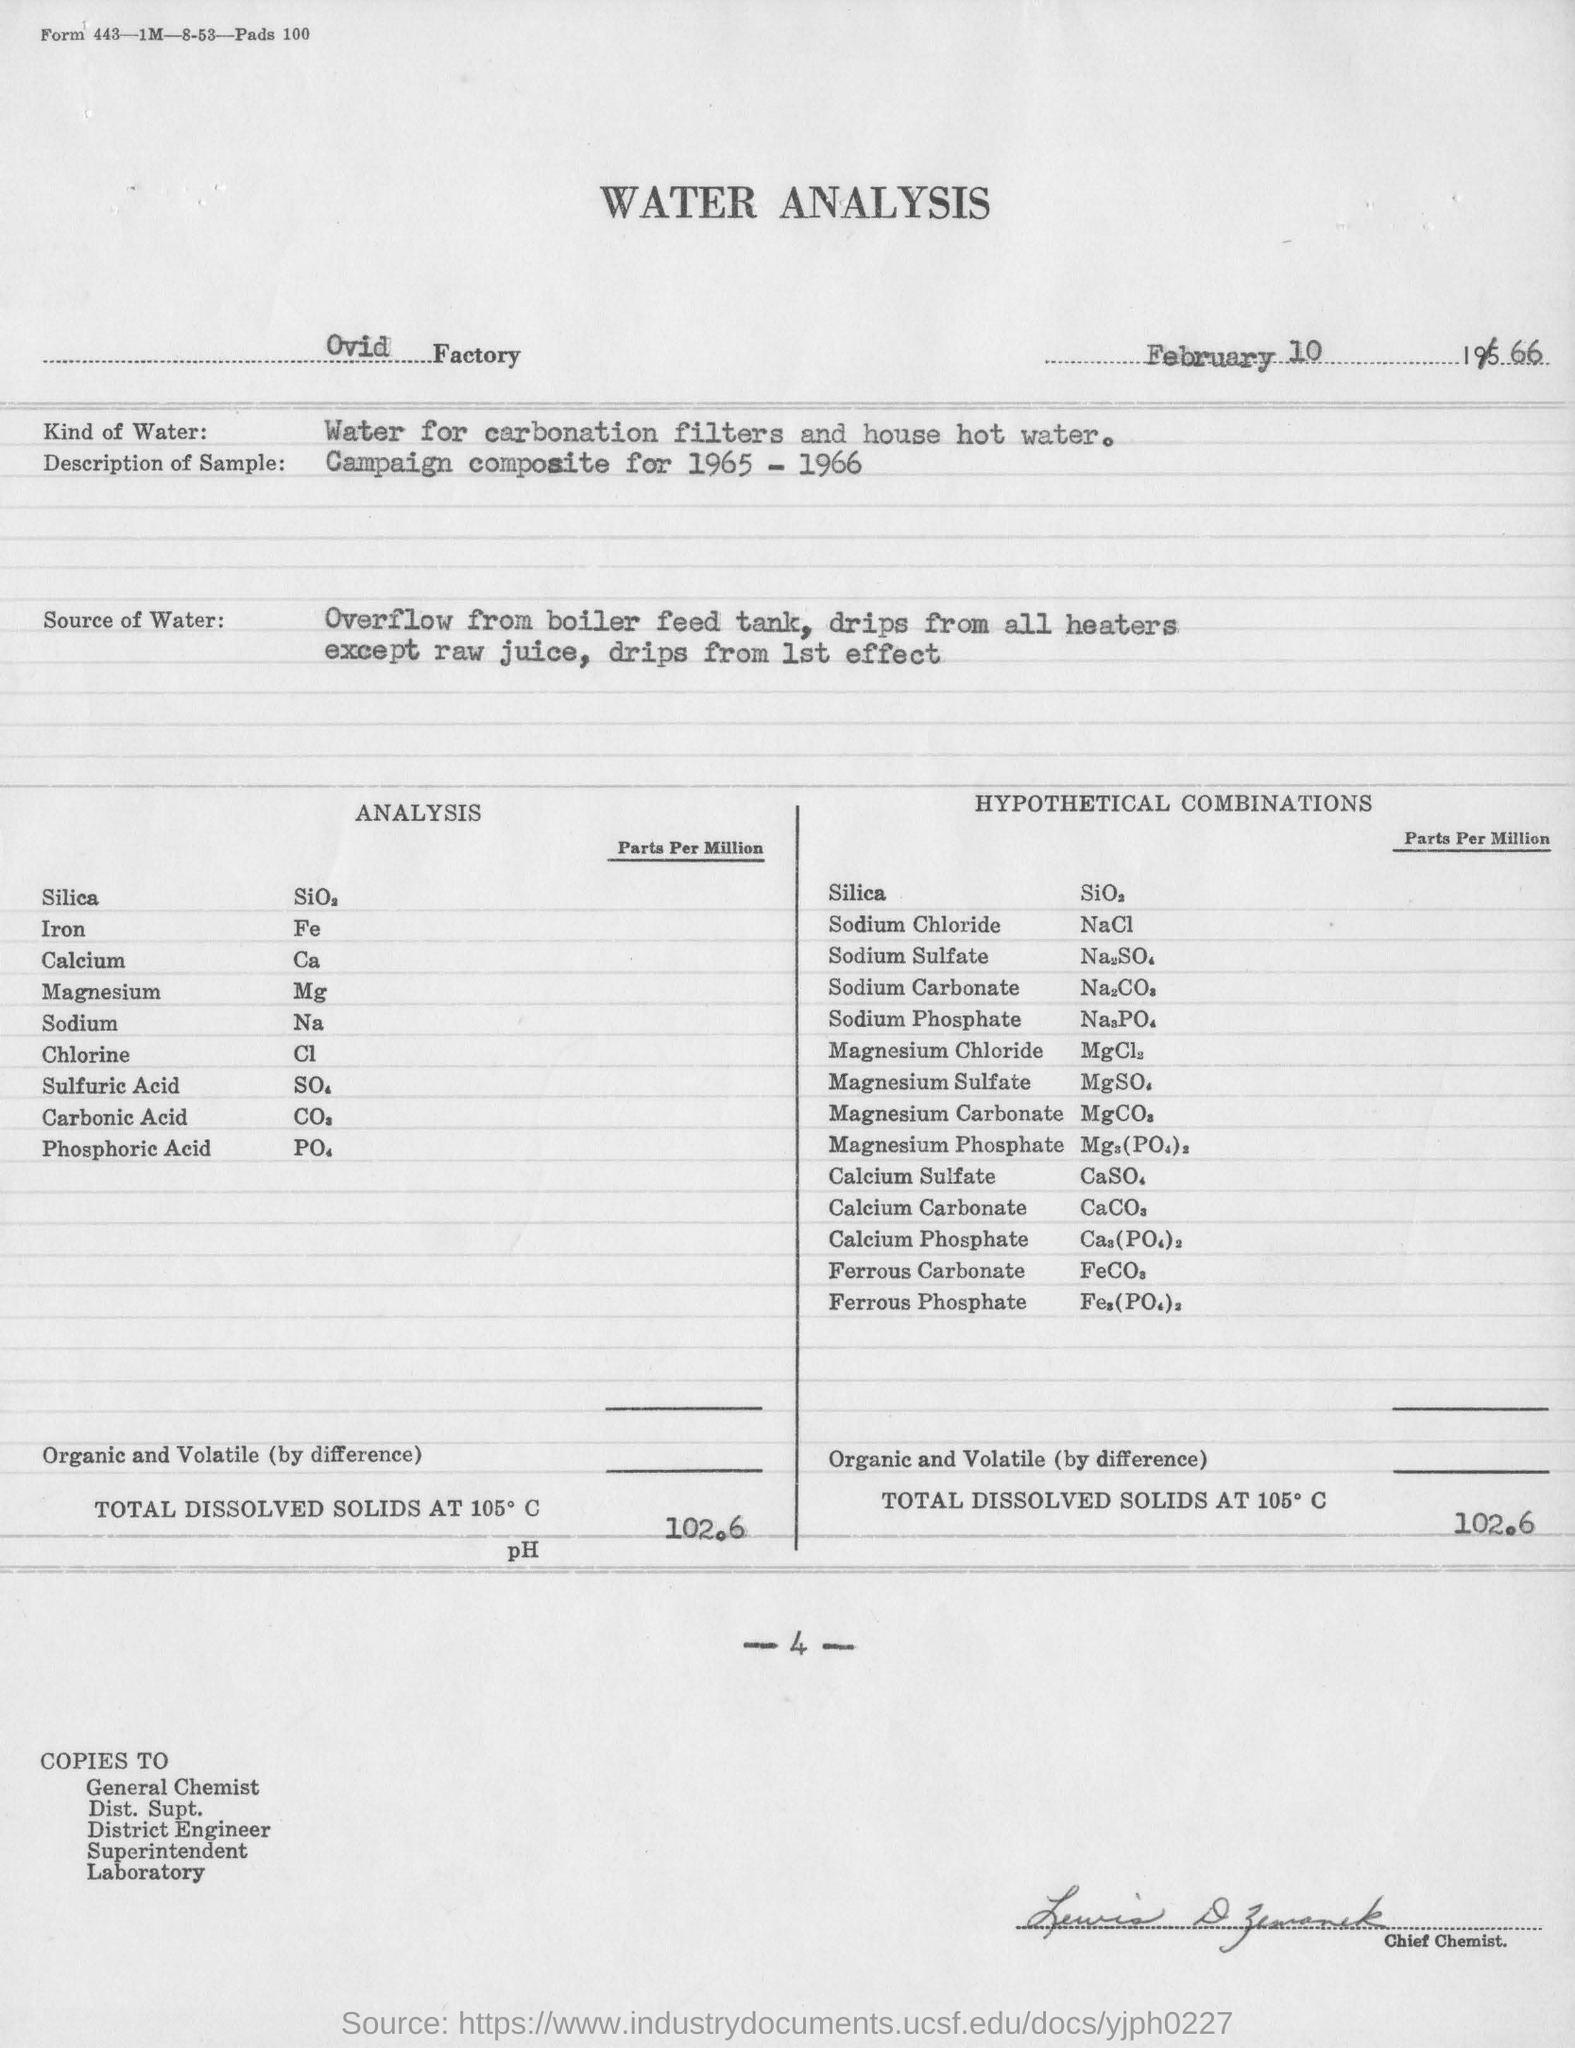Specify some key components in this picture. Nacl" is an abbreviation for "sodium chloride," which is a chemical compound composed of equal amounts of sodium and chlorine atoms. The water analysis was conducted on February 10th. The water analysis is done at the factory, as per Ovid's guidelines. The amount of total dissolved solids at 105 degrees Celsius is [insert value]. The type of water used for water analysis is different from the water used for carbonation filters and house hot water. 